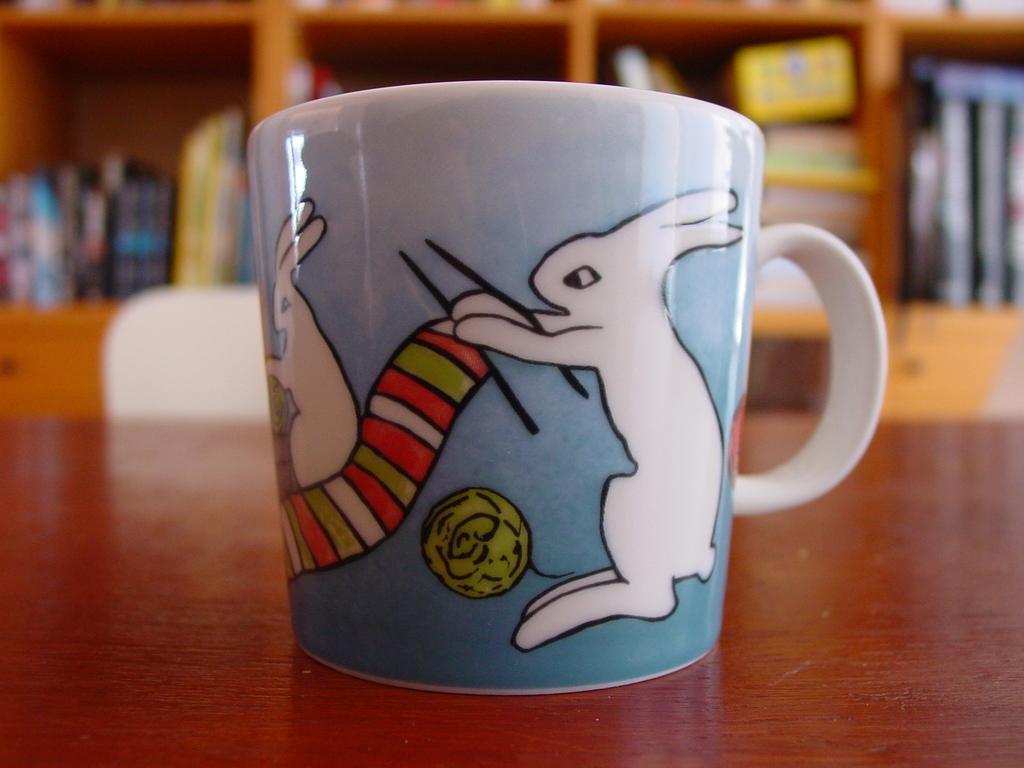Describe this image in one or two sentences. In the foreground of this image, there is a cup on the wooden surface. In the background, there is a chair and few objects and books in the shelf. 